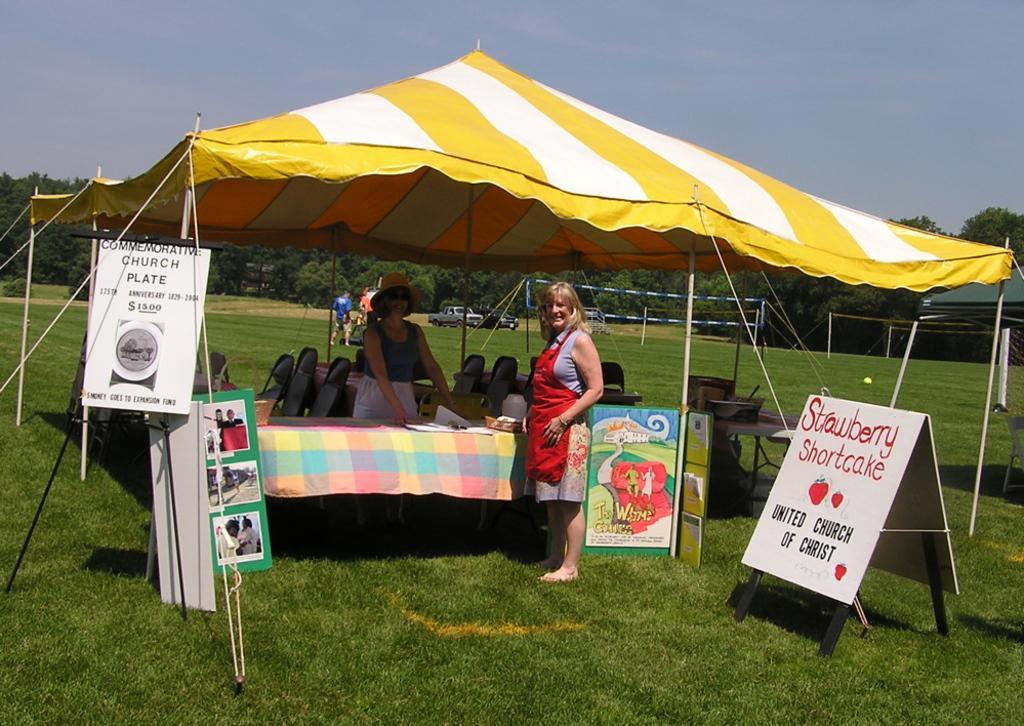How would you summarize this image in a sentence or two? In this picture we can see tents, name board, posters, tables, chairs on the grass, two women smiling and at the back of these two women we can see vehicles, person, trees, some objects and in the background we can see the sky. 